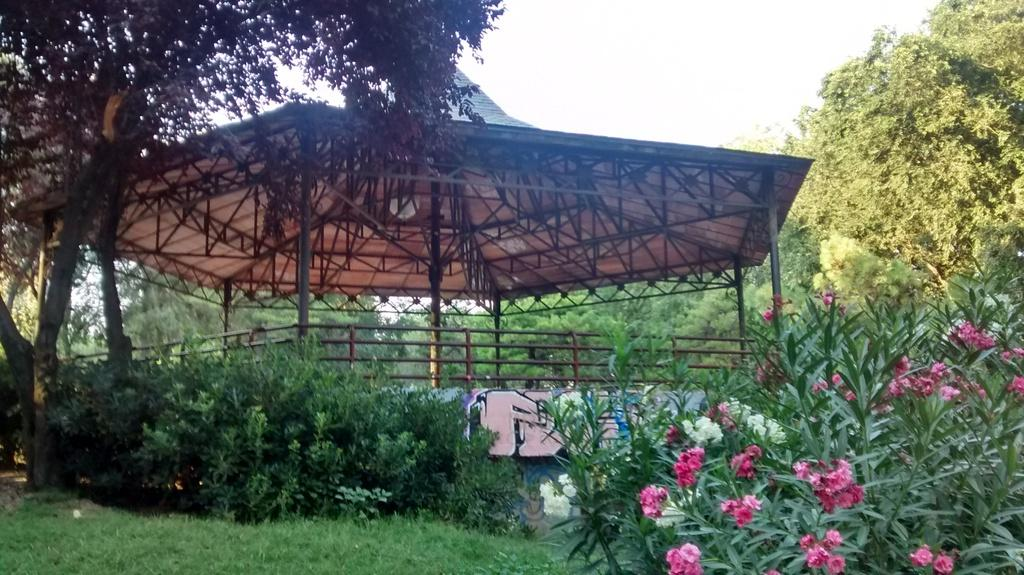What type of vegetation can be seen in the image? There are trees in the image. What type of structure is present in the image? There is a shed in the image. What is visible in the background of the image? The sky is visible in the image. What team is responsible for maintaining the comfort of the trees in the image? There is no information about a team or comfort maintenance in the image; it simply shows trees and a shed. 